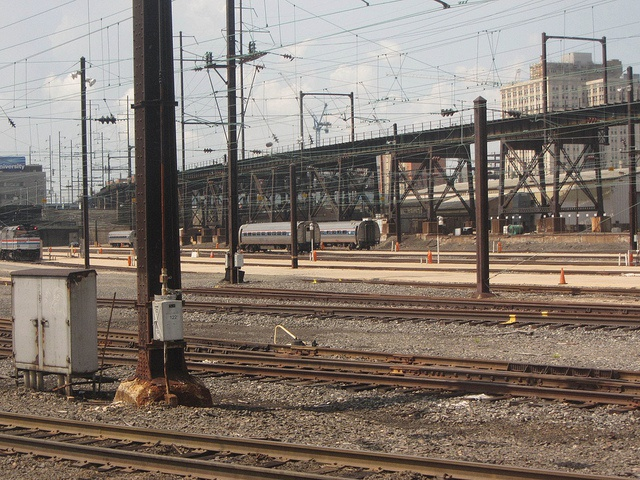Describe the objects in this image and their specific colors. I can see train in lightgray, gray, darkgray, and black tones, train in lightgray, black, gray, and darkgray tones, train in lightgray, black, gray, and darkgray tones, and train in lightgray, gray, and darkgray tones in this image. 